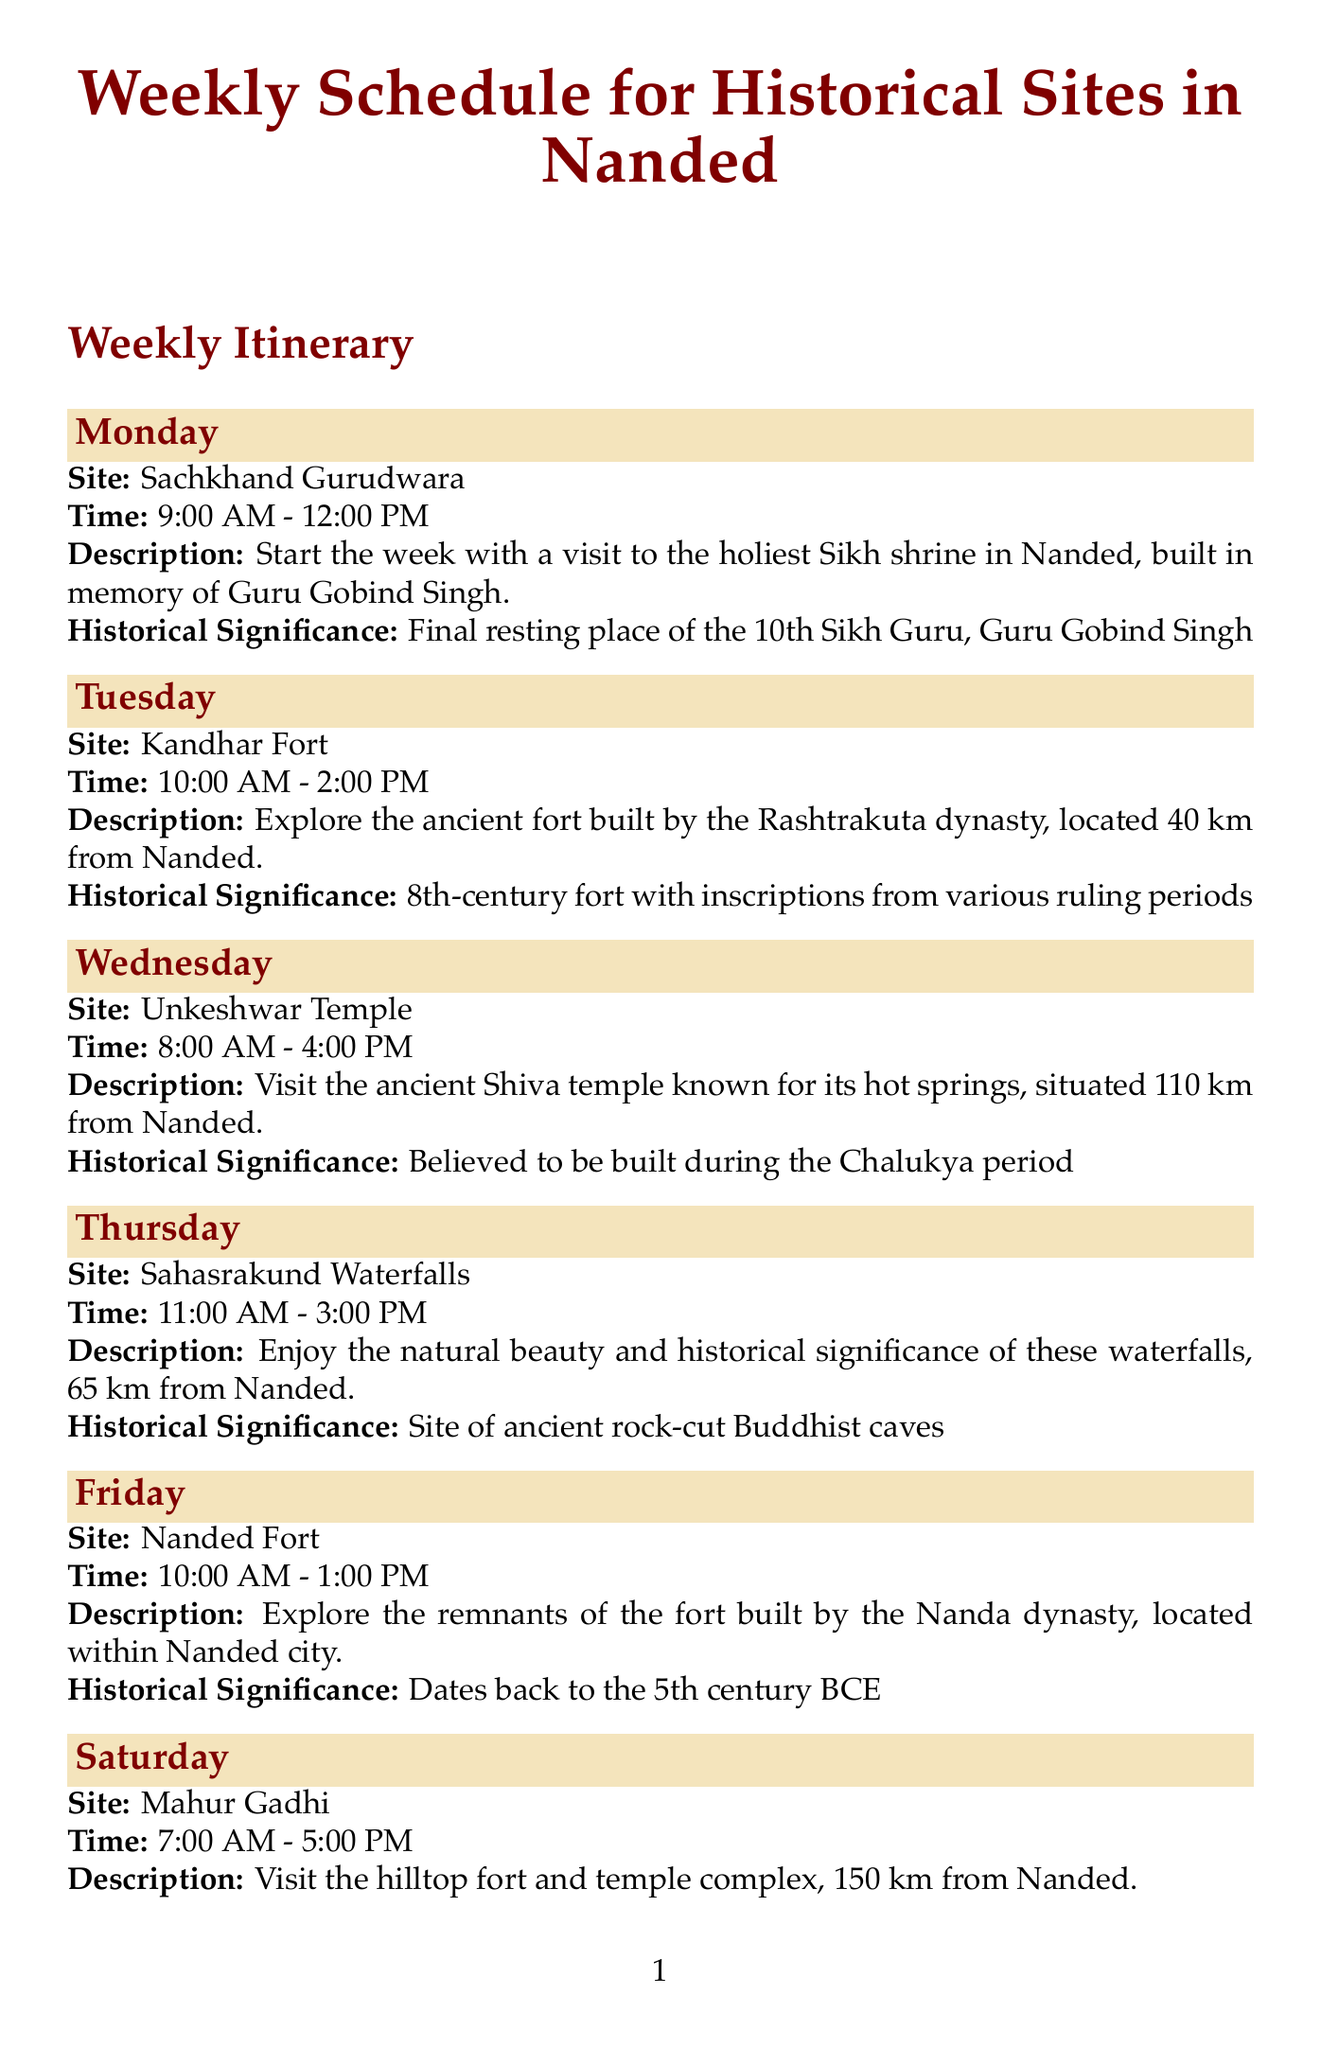What is the site visited on Monday? The document specifies the site visited on Monday as Sachkhand Gurudwara.
Answer: Sachkhand Gurudwara What time is the Nanded Fort visit scheduled? According to the schedule, the visit to Nanded Fort is from 10:00 AM to 1:00 PM.
Answer: 10:00 AM - 1:00 PM Which day is set for visiting Mahur Gadhi? The day allocated for visiting Mahur Gadhi is Saturday.
Answer: Saturday What is the historical significance of Sahasrakund Waterfalls? The document mentions that Sahasrakund Waterfalls is a site of ancient rock-cut Buddhist caves.
Answer: Site of ancient rock-cut Buddhist caves How far is Unkeshwar Temple from Nanded? The schedule states that Unkeshwar Temple is located 110 km from Nanded.
Answer: 110 km What is the best season to visit historical sites in Nanded? The document notes that the best season to visit is from October to March.
Answer: October to March 